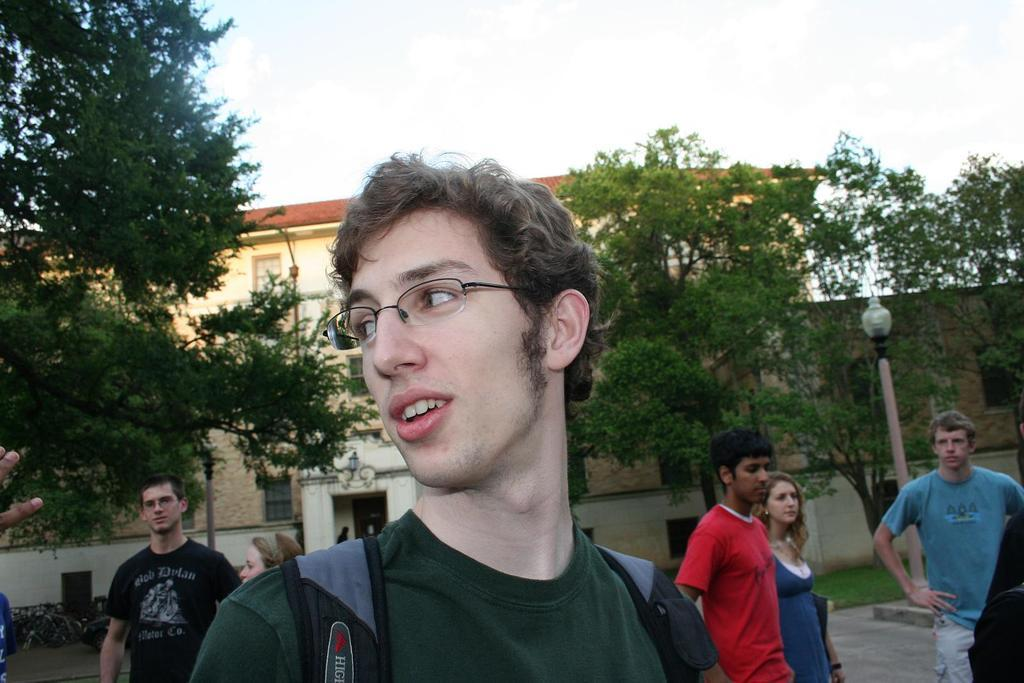What is the main subject of the image? There is a man in the image. Can you describe the man's appearance? The man is wearing glasses. What can be seen in the background of the image? There are people, trees, poles, a house, walls, grass, and a light in the background of the image. What is visible at the top of the image? The sky is visible at the top of the image. What type of hose is being used by the man in the image? There is no hose present in the image. Can you tell me how many needles are being held by the man in the image? There are no needles present in the image. 